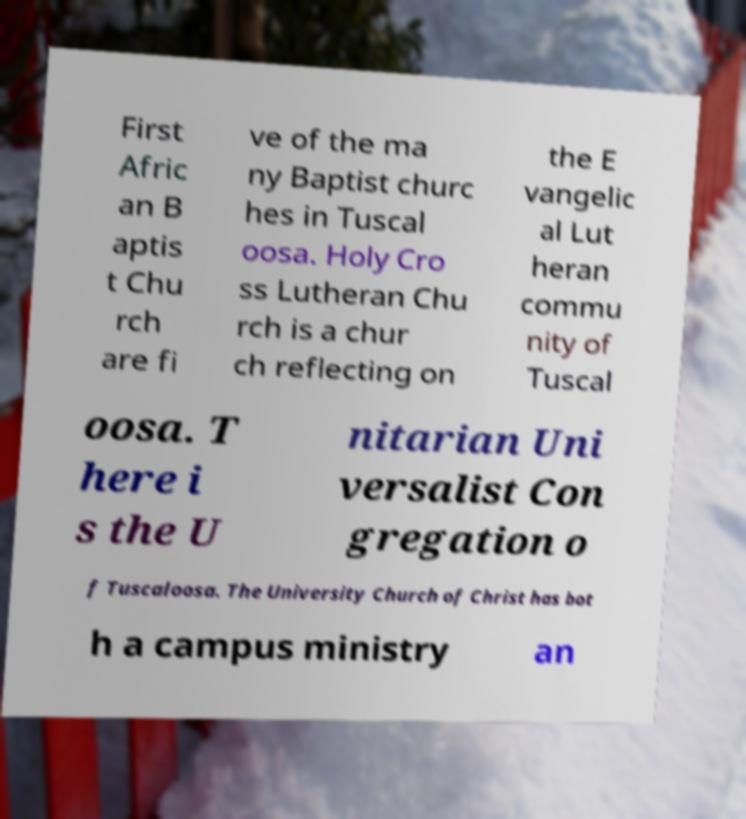There's text embedded in this image that I need extracted. Can you transcribe it verbatim? First Afric an B aptis t Chu rch are fi ve of the ma ny Baptist churc hes in Tuscal oosa. Holy Cro ss Lutheran Chu rch is a chur ch reflecting on the E vangelic al Lut heran commu nity of Tuscal oosa. T here i s the U nitarian Uni versalist Con gregation o f Tuscaloosa. The University Church of Christ has bot h a campus ministry an 